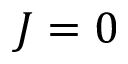<formula> <loc_0><loc_0><loc_500><loc_500>J = 0</formula> 